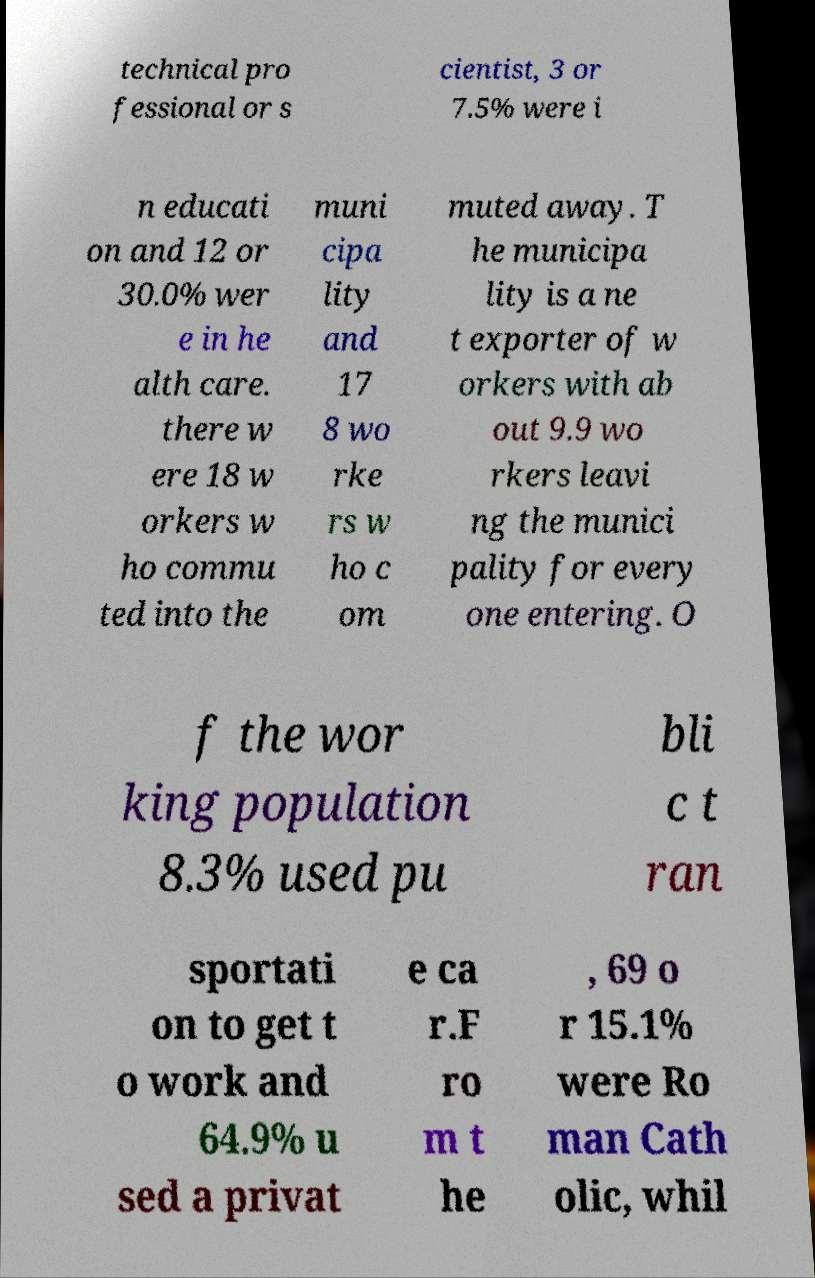I need the written content from this picture converted into text. Can you do that? technical pro fessional or s cientist, 3 or 7.5% were i n educati on and 12 or 30.0% wer e in he alth care. there w ere 18 w orkers w ho commu ted into the muni cipa lity and 17 8 wo rke rs w ho c om muted away. T he municipa lity is a ne t exporter of w orkers with ab out 9.9 wo rkers leavi ng the munici pality for every one entering. O f the wor king population 8.3% used pu bli c t ran sportati on to get t o work and 64.9% u sed a privat e ca r.F ro m t he , 69 o r 15.1% were Ro man Cath olic, whil 